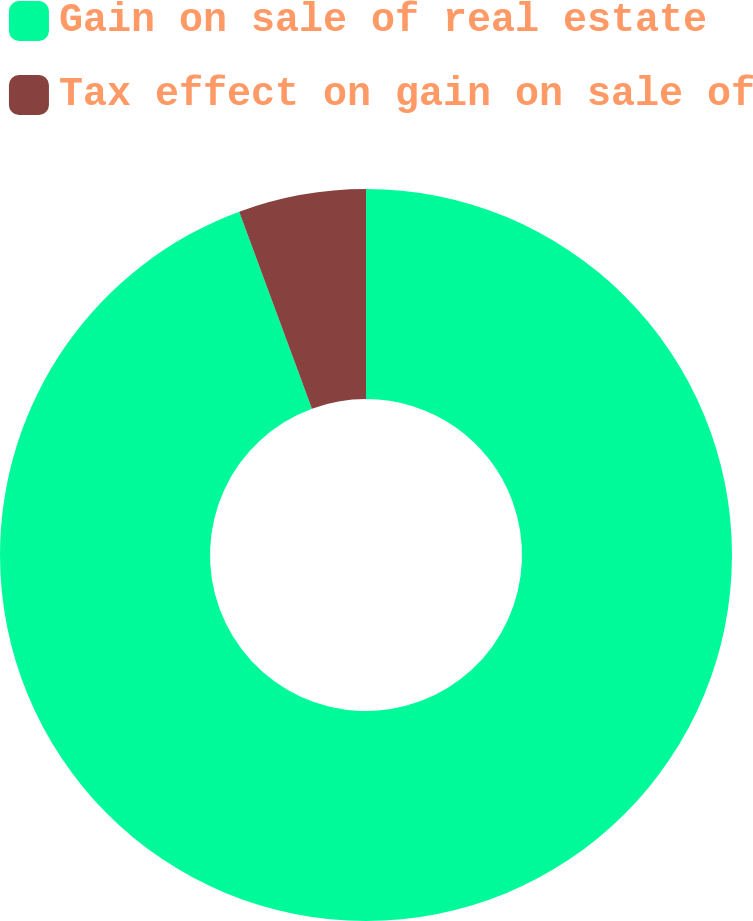<chart> <loc_0><loc_0><loc_500><loc_500><pie_chart><fcel>Gain on sale of real estate<fcel>Tax effect on gain on sale of<nl><fcel>94.37%<fcel>5.63%<nl></chart> 